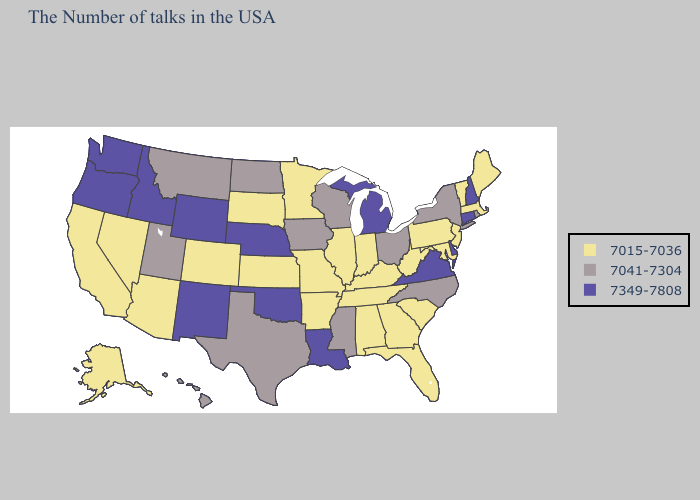Name the states that have a value in the range 7349-7808?
Short answer required. New Hampshire, Connecticut, Delaware, Virginia, Michigan, Louisiana, Nebraska, Oklahoma, Wyoming, New Mexico, Idaho, Washington, Oregon. What is the highest value in states that border Kansas?
Write a very short answer. 7349-7808. Name the states that have a value in the range 7015-7036?
Give a very brief answer. Maine, Massachusetts, Vermont, New Jersey, Maryland, Pennsylvania, South Carolina, West Virginia, Florida, Georgia, Kentucky, Indiana, Alabama, Tennessee, Illinois, Missouri, Arkansas, Minnesota, Kansas, South Dakota, Colorado, Arizona, Nevada, California, Alaska. Name the states that have a value in the range 7041-7304?
Short answer required. Rhode Island, New York, North Carolina, Ohio, Wisconsin, Mississippi, Iowa, Texas, North Dakota, Utah, Montana, Hawaii. What is the highest value in the USA?
Write a very short answer. 7349-7808. Does Wyoming have the lowest value in the West?
Answer briefly. No. What is the value of Oregon?
Short answer required. 7349-7808. What is the lowest value in the South?
Answer briefly. 7015-7036. Does Ohio have the lowest value in the MidWest?
Write a very short answer. No. What is the value of North Carolina?
Short answer required. 7041-7304. Does Oklahoma have the same value as Maryland?
Quick response, please. No. Does Maryland have the highest value in the South?
Be succinct. No. Name the states that have a value in the range 7041-7304?
Short answer required. Rhode Island, New York, North Carolina, Ohio, Wisconsin, Mississippi, Iowa, Texas, North Dakota, Utah, Montana, Hawaii. Which states have the highest value in the USA?
Answer briefly. New Hampshire, Connecticut, Delaware, Virginia, Michigan, Louisiana, Nebraska, Oklahoma, Wyoming, New Mexico, Idaho, Washington, Oregon. Which states have the lowest value in the South?
Concise answer only. Maryland, South Carolina, West Virginia, Florida, Georgia, Kentucky, Alabama, Tennessee, Arkansas. 